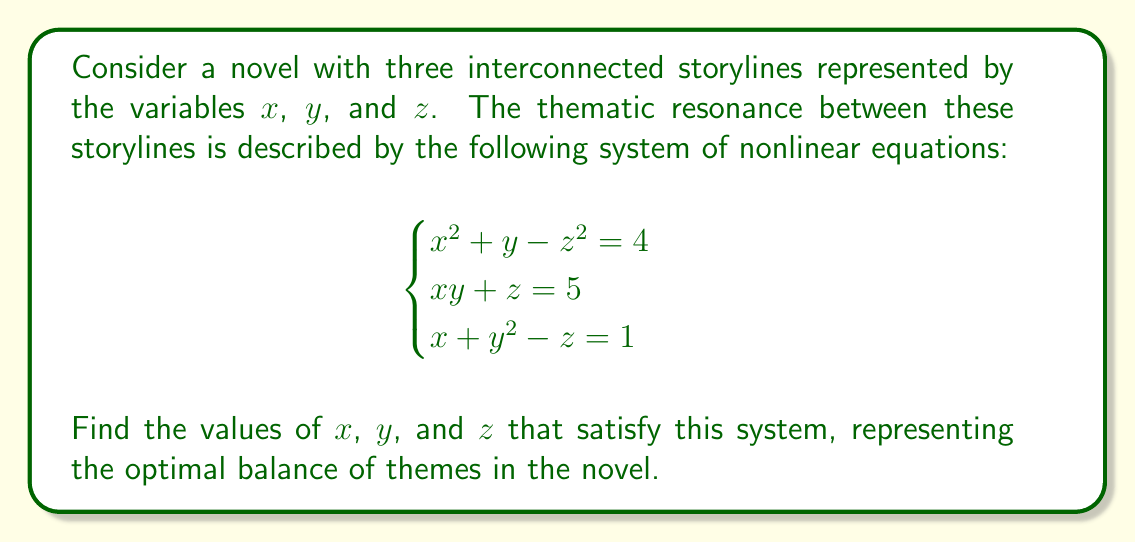Give your solution to this math problem. To solve this system of nonlinear equations, we'll use substitution and elimination methods:

1) From the second equation, we can express $z$ in terms of $x$ and $y$:
   $z = 5 - xy$

2) Substitute this into the first and third equations:
   $x^2 + y - (5-xy)^2 = 4$
   $x + y^2 - (5-xy) = 1$

3) Simplify the first equation:
   $x^2 + y - (25 - 10xy + x^2y^2) = 4$
   $x^2 + y - 25 + 10xy - x^2y^2 = 4$
   $-x^2y^2 + 10xy + x^2 + y - 29 = 0$ ... (Eq. 1)

4) Simplify the second equation:
   $x + y^2 - 5 + xy = 1$
   $xy + y^2 + x - 6 = 0$ ... (Eq. 2)

5) From Eq. 2, express $x$ in terms of $y$:
   $x(y+1) = 6 - y^2$
   $x = \frac{6-y^2}{y+1}$

6) Substitute this into Eq. 1:
   $-(\frac{6-y^2}{y+1})^2y^2 + 10(\frac{6-y^2}{y+1})y + (\frac{6-y^2}{y+1})^2 + y - 29 = 0$

7) Multiply everything by $(y+1)^2$:
   $-(6-y^2)^2y^2 + 10(6-y^2)(y+1)y + (6-y^2)^2 + y(y+1)^2 - 29(y+1)^2 = 0$

8) Expand and simplify this equation. It will result in a 6th-degree polynomial in $y$:
   $y^6 + 3y^5 - 10y^4 - 30y^3 + 9y^2 + 27y - 54 = 0$

9) This polynomial has a rational root $y = 2$. We can verify this by substitution.

10) With $y = 2$, we can find $x$ from the equation in step 5:
    $x = \frac{6-2^2}{2+1} = \frac{2}{3}$

11) Finally, we can find $z$ from the original second equation:
    $z = 5 - xy = 5 - \frac{2}{3} \cdot 2 = \frac{11}{3}$

Therefore, the solution is $x = \frac{2}{3}$, $y = 2$, and $z = \frac{11}{3}$.
Answer: $x = \frac{2}{3}$, $y = 2$, $z = \frac{11}{3}$ 